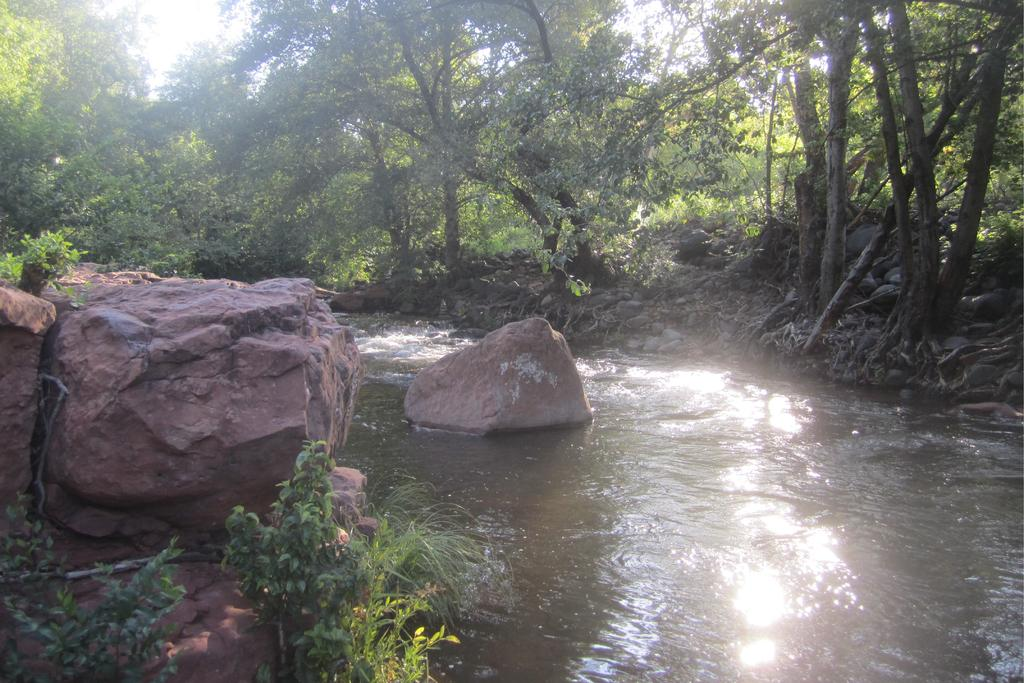What type of body of water is present in the image? There is a lake in the image. What can be seen in the lake? There are stones visible in the lake. What type of vegetation is present in the image? There are trees visible in the middle of the image. What type of government is depicted in the image? There is no depiction of a government in the image; it features a lake with stones and trees. What trick is being performed in the image? There is no trick being performed in the image; it is a natural scene featuring a lake, stones, and trees. 